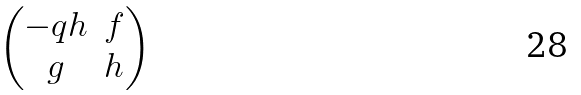<formula> <loc_0><loc_0><loc_500><loc_500>\begin{pmatrix} - q h & f \\ g & h \end{pmatrix}</formula> 